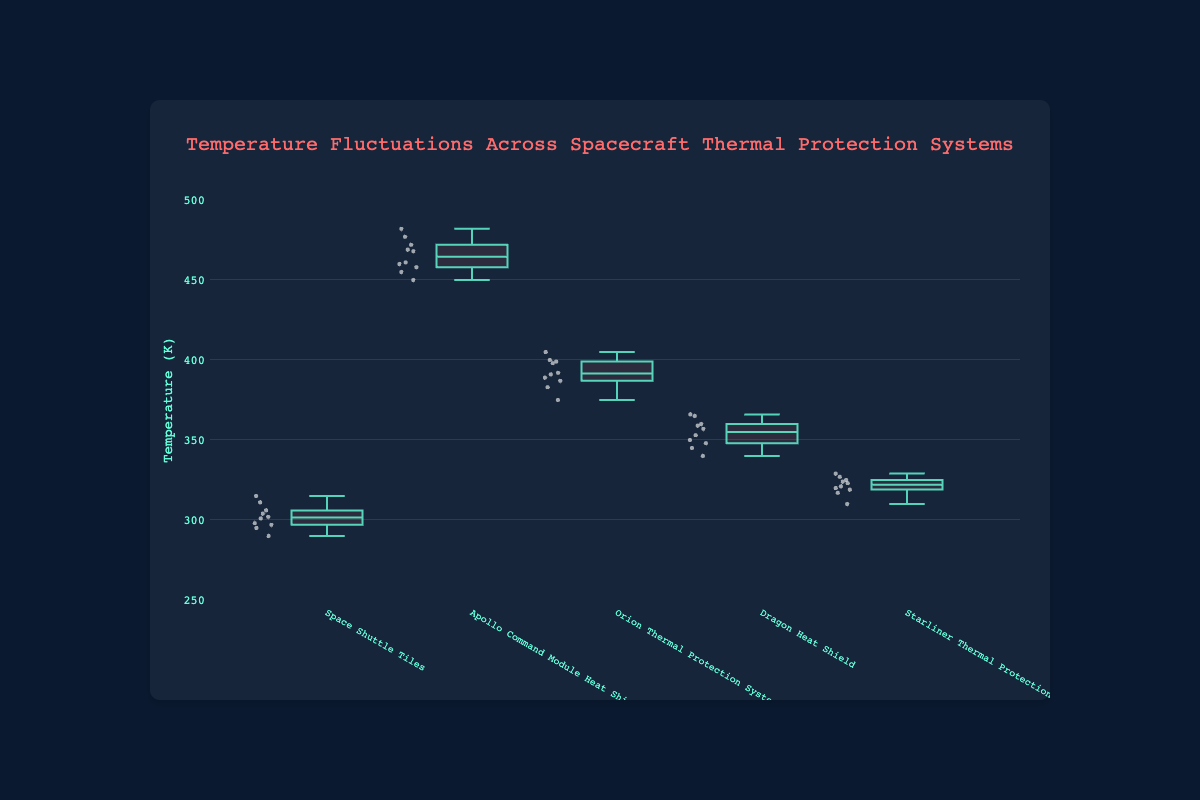What is the title of the plot? The title is displayed at the top of the figure, it reads 'Temperature Fluctuations Across Spacecraft Thermal Protection Systems'.
Answer: Temperature Fluctuations Across Spacecraft Thermal Protection Systems Which thermal protection system has the highest median temperature? The box plot shows a line across the middle of each box which represents the median. The Apollo Command Module Heat Shield has the highest median temperature.
Answer: Apollo Command Module Heat Shield What is the temperature range of the Space Shuttle Tiles? The range of a box plot is the difference between the highest and lowest temperature points. For the Space Shuttle Tiles, the lowest temperature is 290K and the highest is 315K, so the range is 315 - 290.
Answer: 25K Which spacecraft thermal protection system has the narrowest interquartile range (IQR)? The IQR is the difference between the third quartile (Q3) and the first quartile (Q1). The Starliner Thermal Protection System has the narrowest IQR as its box (middle 50% of the data) is the most compressed.
Answer: Starliner Thermal Protection System What is the median temperature of the Orion Thermal Protection System? Identify the median line inside the box for the Orion Thermal Protection System. The median temperature is where this line is located.
Answer: 392K Which system shows the largest temperature fluctuation (range between max and min values)? Temperature fluctuation is seen in the range. The Apollo Command Module Heat Shield shows the largest fluctuation with a range from approximately 450K to 482K.
Answer: Apollo Command Module Heat Shield How many data points are used for the Dragon Heat Shield? Counting the individual points displayed for the data set of the Dragon Heat Shield including outliers gives the total number of data points.
Answer: 10 Which two systems have their interquartile ranges (IQRs) overlapping? To identify overlapping IQRs, look for boxes that overlap on the temperature axis. The Space Shuttle Tiles and Starliner Thermal Protection System IQRs overlap.
Answer: Space Shuttle Tiles and Starliner Thermal Protection System What is the approximate median temperature difference between the Dragon Heat Shield and the Orion Thermal Protection System? Compare the median lines of the Dragon Heat Shield and the Orion Thermal Protection System. The difference is approximately the value of the Orion median minus the Dragon median.
Answer: 392K - 353K = 39K What is the approximate interquartile range (IQR) for the Apollo Command Module Heat Shield? The IQR can be estimated by subtracting the first quartile (lower edge of the box) from the third quartile (upper edge). For Apollo, it is approximately 469 - 455.
Answer: 14K 